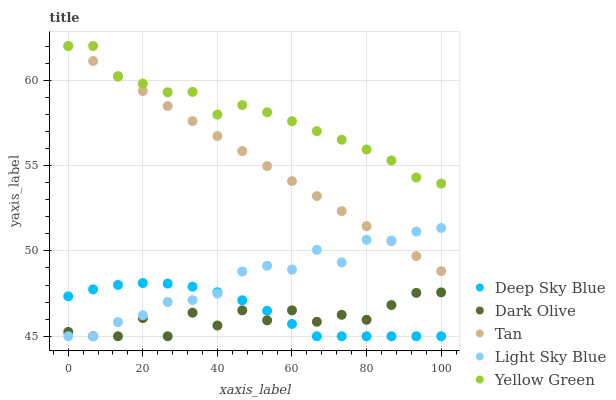Does Dark Olive have the minimum area under the curve?
Answer yes or no. Yes. Does Yellow Green have the maximum area under the curve?
Answer yes or no. Yes. Does Yellow Green have the minimum area under the curve?
Answer yes or no. No. Does Dark Olive have the maximum area under the curve?
Answer yes or no. No. Is Tan the smoothest?
Answer yes or no. Yes. Is Dark Olive the roughest?
Answer yes or no. Yes. Is Yellow Green the smoothest?
Answer yes or no. No. Is Yellow Green the roughest?
Answer yes or no. No. Does Dark Olive have the lowest value?
Answer yes or no. Yes. Does Yellow Green have the lowest value?
Answer yes or no. No. Does Yellow Green have the highest value?
Answer yes or no. Yes. Does Dark Olive have the highest value?
Answer yes or no. No. Is Dark Olive less than Tan?
Answer yes or no. Yes. Is Yellow Green greater than Light Sky Blue?
Answer yes or no. Yes. Does Tan intersect Yellow Green?
Answer yes or no. Yes. Is Tan less than Yellow Green?
Answer yes or no. No. Is Tan greater than Yellow Green?
Answer yes or no. No. Does Dark Olive intersect Tan?
Answer yes or no. No. 